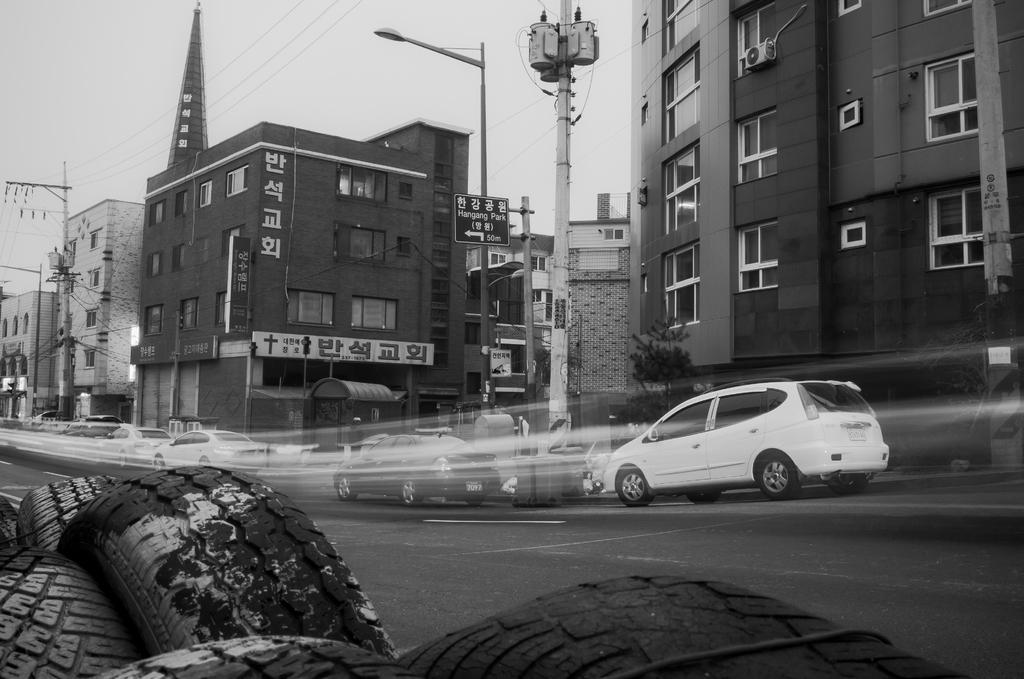What is the color scheme of the image? The image is black and white. What can be seen on the left side of the image? There are tyres on the left side of the image. What is happening in the middle of the image? There are cars moving in the middle of the image. What structures are visible on the right side of the image? There are buildings on the right side of the image. Where is the sugar factory located in the image? There is no sugar factory present in the image. Can you tell me how many people are in jail in the image? There is no jail or any indication of people being in jail in the image. 